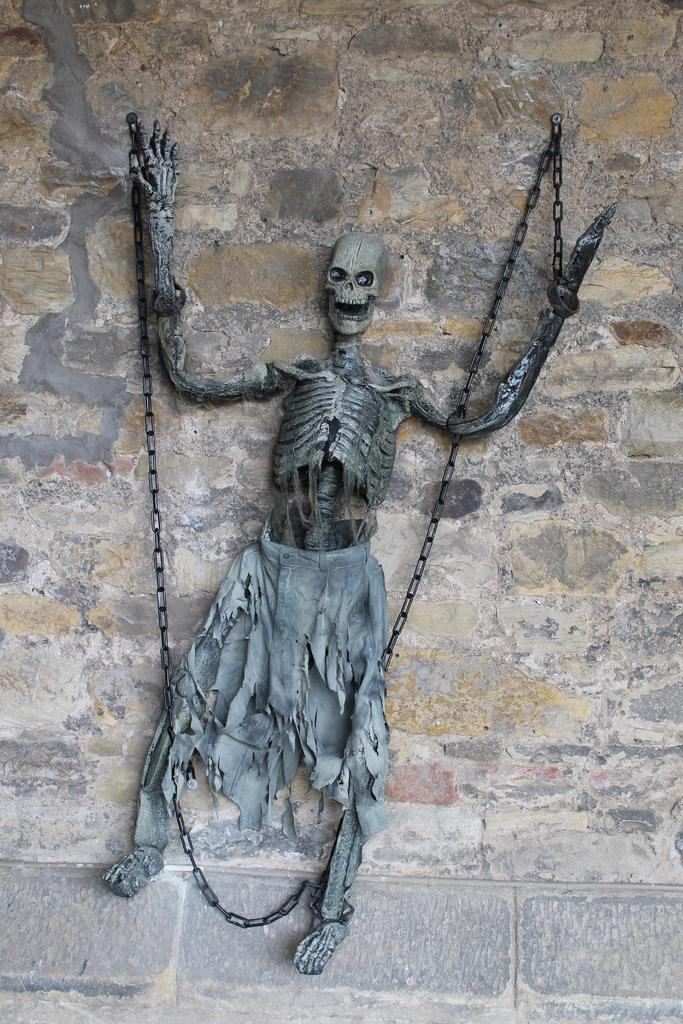What is the main subject of the image? There is a skeleton in the image. What is the color of the skeleton? The skeleton is grey in color. What is attached to the skeleton? There is a metal chain attached to the skeleton. What is associated with the metal chain? There is cloth associated with the metal chain. What can be seen in the background of the image? There is a wall visible in the background of the image. What type of paste is being used to hold the skeleton together in the image? There is no paste present in the image, as the skeleton is likely a prop or artistic representation. 